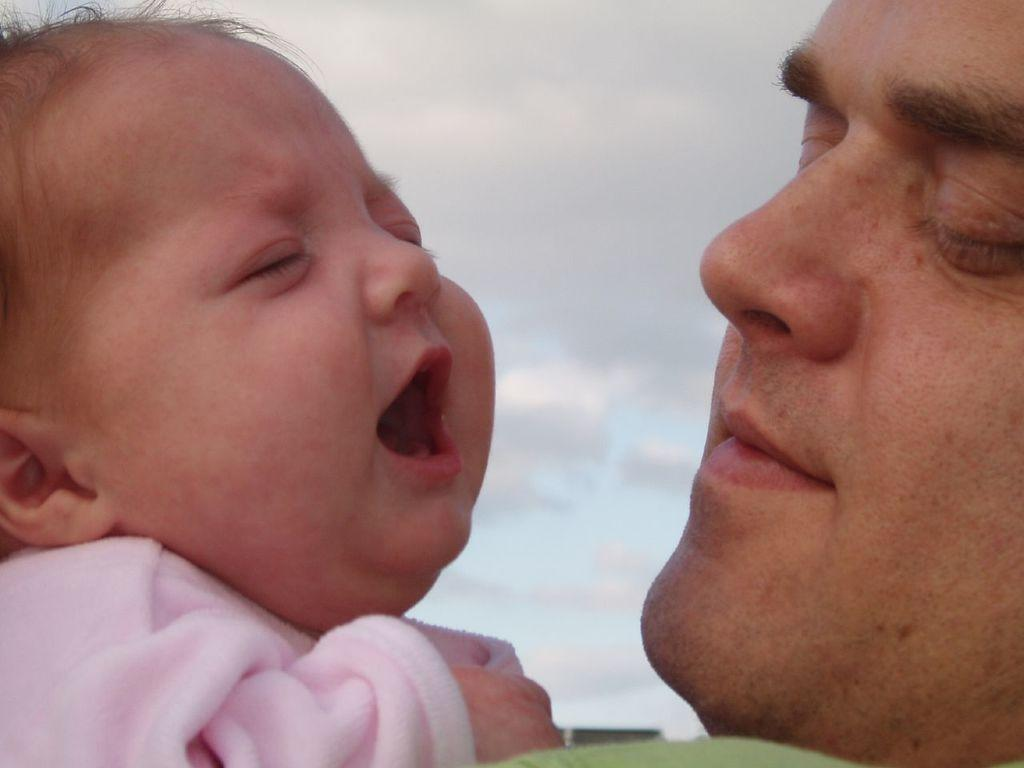What is the primary subject of the image? There is a man in the image. Can you identify any other people in the image? Yes, there is a baby in the image. What can be seen in the background of the image? There is a sky with clouds visible in the background of the image. What type of riddle can be seen being solved by the man in the image? There is no riddle present in the image; it features a man and a baby in an unspecified setting. Is the man wearing a scarf in the image? There is no mention of a scarf in the image, and it cannot be determined from the provided facts. 